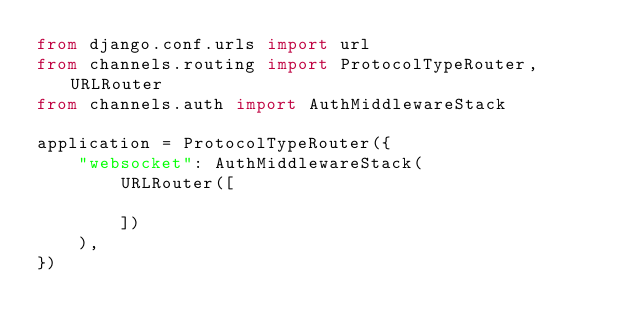Convert code to text. <code><loc_0><loc_0><loc_500><loc_500><_Python_>from django.conf.urls import url
from channels.routing import ProtocolTypeRouter, URLRouter
from channels.auth import AuthMiddlewareStack

application = ProtocolTypeRouter({
    "websocket": AuthMiddlewareStack(
        URLRouter([
            
        ])
    ),
})</code> 